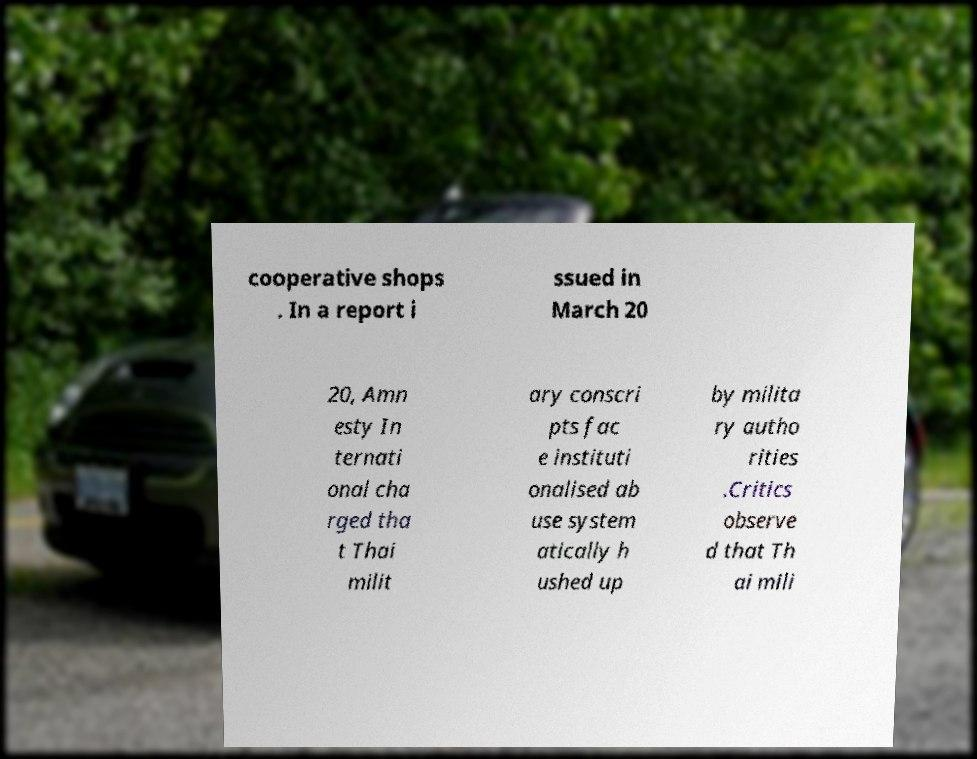For documentation purposes, I need the text within this image transcribed. Could you provide that? cooperative shops . In a report i ssued in March 20 20, Amn esty In ternati onal cha rged tha t Thai milit ary conscri pts fac e instituti onalised ab use system atically h ushed up by milita ry autho rities .Critics observe d that Th ai mili 